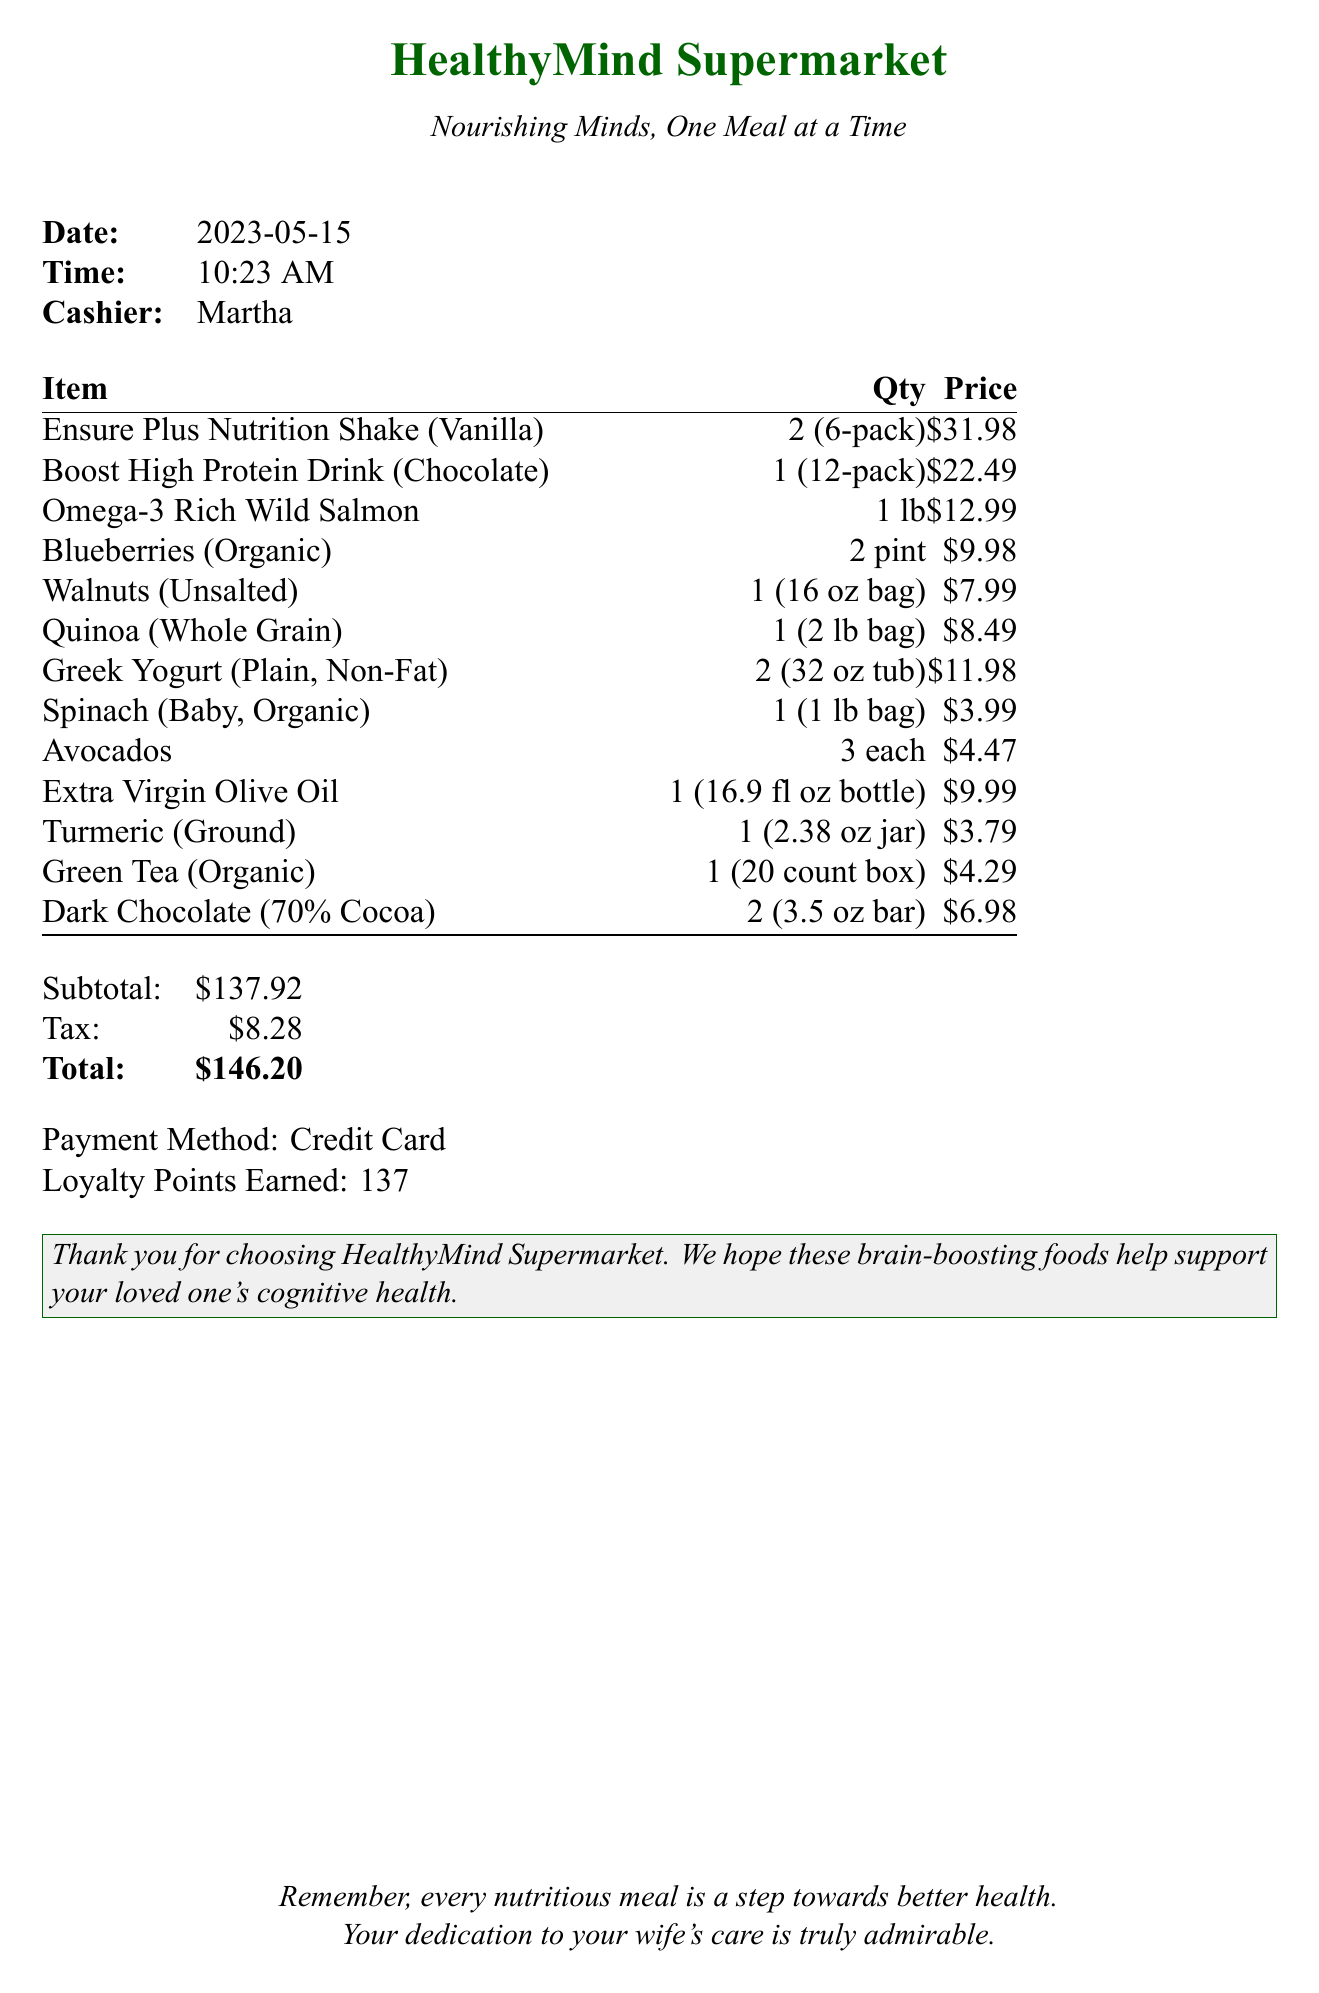What is the store name? The store name is located at the top of the receipt.
Answer: HealthyMind Supermarket What was the date of purchase? The date of purchase is listed in the document.
Answer: 2023-05-15 How many Ensure Plus Nutrition Shakes were purchased? The quantity of Ensure Plus Nutrition Shakes is specified in the items list.
Answer: 2 What is the total amount spent? The total amount is found at the bottom section of the receipt.
Answer: $146.20 Who was the cashier? The cashier's name is mentioned in the document under cashier information.
Answer: Martha What type of drink was included in the purchase? A specific drink type is listed under the items bought.
Answer: Boost High Protein Drink What is the loyalty points earned from this purchase? The loyalty points are stated in the payment details of the receipt.
Answer: 137 What type of oil was purchased? The type of oil is mentioned in the items list.
Answer: Extra Virgin Olive Oil How many pints of blueberries were bought? The number of pints is noted in the item description on the receipt.
Answer: 2 pint 